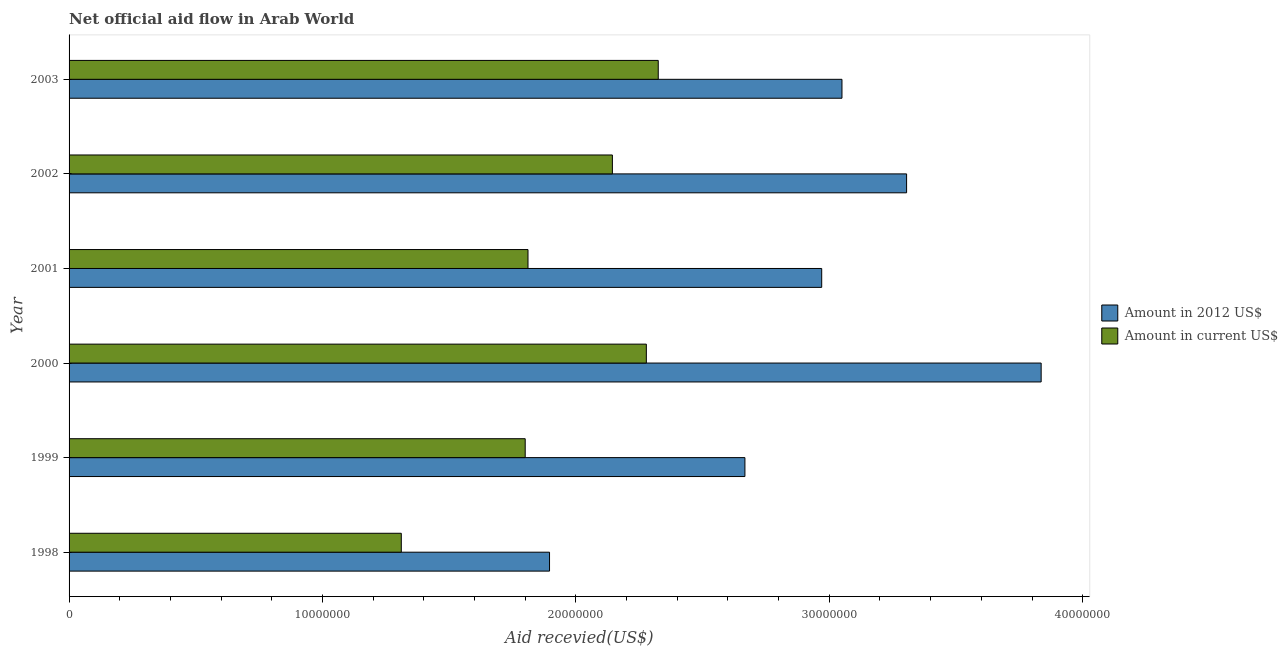How many different coloured bars are there?
Make the answer very short. 2. How many groups of bars are there?
Provide a short and direct response. 6. Are the number of bars on each tick of the Y-axis equal?
Offer a terse response. Yes. How many bars are there on the 2nd tick from the bottom?
Your answer should be very brief. 2. What is the label of the 2nd group of bars from the top?
Offer a very short reply. 2002. In how many cases, is the number of bars for a given year not equal to the number of legend labels?
Your answer should be compact. 0. What is the amount of aid received(expressed in 2012 us$) in 2002?
Your answer should be very brief. 3.30e+07. Across all years, what is the maximum amount of aid received(expressed in us$)?
Offer a very short reply. 2.32e+07. Across all years, what is the minimum amount of aid received(expressed in us$)?
Keep it short and to the point. 1.31e+07. In which year was the amount of aid received(expressed in 2012 us$) maximum?
Give a very brief answer. 2000. What is the total amount of aid received(expressed in us$) in the graph?
Give a very brief answer. 1.17e+08. What is the difference between the amount of aid received(expressed in 2012 us$) in 2002 and that in 2003?
Offer a terse response. 2.55e+06. What is the difference between the amount of aid received(expressed in us$) in 1998 and the amount of aid received(expressed in 2012 us$) in 1999?
Give a very brief answer. -1.36e+07. What is the average amount of aid received(expressed in us$) per year?
Your response must be concise. 1.94e+07. In the year 2002, what is the difference between the amount of aid received(expressed in us$) and amount of aid received(expressed in 2012 us$)?
Keep it short and to the point. -1.16e+07. What is the ratio of the amount of aid received(expressed in us$) in 2001 to that in 2003?
Provide a succinct answer. 0.78. What is the difference between the highest and the lowest amount of aid received(expressed in 2012 us$)?
Ensure brevity in your answer.  1.94e+07. In how many years, is the amount of aid received(expressed in us$) greater than the average amount of aid received(expressed in us$) taken over all years?
Offer a very short reply. 3. Is the sum of the amount of aid received(expressed in us$) in 2000 and 2001 greater than the maximum amount of aid received(expressed in 2012 us$) across all years?
Provide a succinct answer. Yes. What does the 1st bar from the top in 1999 represents?
Provide a short and direct response. Amount in current US$. What does the 1st bar from the bottom in 1999 represents?
Provide a short and direct response. Amount in 2012 US$. Are all the bars in the graph horizontal?
Make the answer very short. Yes. What is the difference between two consecutive major ticks on the X-axis?
Provide a succinct answer. 1.00e+07. Does the graph contain any zero values?
Your answer should be very brief. No. Where does the legend appear in the graph?
Provide a succinct answer. Center right. How many legend labels are there?
Offer a terse response. 2. What is the title of the graph?
Keep it short and to the point. Net official aid flow in Arab World. Does "Number of arrivals" appear as one of the legend labels in the graph?
Your response must be concise. No. What is the label or title of the X-axis?
Your answer should be compact. Aid recevied(US$). What is the label or title of the Y-axis?
Your response must be concise. Year. What is the Aid recevied(US$) of Amount in 2012 US$ in 1998?
Your response must be concise. 1.90e+07. What is the Aid recevied(US$) in Amount in current US$ in 1998?
Ensure brevity in your answer.  1.31e+07. What is the Aid recevied(US$) in Amount in 2012 US$ in 1999?
Your answer should be very brief. 2.67e+07. What is the Aid recevied(US$) in Amount in current US$ in 1999?
Keep it short and to the point. 1.80e+07. What is the Aid recevied(US$) of Amount in 2012 US$ in 2000?
Provide a short and direct response. 3.84e+07. What is the Aid recevied(US$) in Amount in current US$ in 2000?
Give a very brief answer. 2.28e+07. What is the Aid recevied(US$) in Amount in 2012 US$ in 2001?
Your answer should be very brief. 2.97e+07. What is the Aid recevied(US$) of Amount in current US$ in 2001?
Your answer should be compact. 1.81e+07. What is the Aid recevied(US$) in Amount in 2012 US$ in 2002?
Your response must be concise. 3.30e+07. What is the Aid recevied(US$) of Amount in current US$ in 2002?
Keep it short and to the point. 2.14e+07. What is the Aid recevied(US$) in Amount in 2012 US$ in 2003?
Provide a succinct answer. 3.05e+07. What is the Aid recevied(US$) of Amount in current US$ in 2003?
Offer a very short reply. 2.32e+07. Across all years, what is the maximum Aid recevied(US$) in Amount in 2012 US$?
Keep it short and to the point. 3.84e+07. Across all years, what is the maximum Aid recevied(US$) in Amount in current US$?
Offer a very short reply. 2.32e+07. Across all years, what is the minimum Aid recevied(US$) in Amount in 2012 US$?
Provide a succinct answer. 1.90e+07. Across all years, what is the minimum Aid recevied(US$) of Amount in current US$?
Make the answer very short. 1.31e+07. What is the total Aid recevied(US$) of Amount in 2012 US$ in the graph?
Your answer should be compact. 1.77e+08. What is the total Aid recevied(US$) in Amount in current US$ in the graph?
Your answer should be very brief. 1.17e+08. What is the difference between the Aid recevied(US$) of Amount in 2012 US$ in 1998 and that in 1999?
Provide a succinct answer. -7.71e+06. What is the difference between the Aid recevied(US$) in Amount in current US$ in 1998 and that in 1999?
Make the answer very short. -4.89e+06. What is the difference between the Aid recevied(US$) of Amount in 2012 US$ in 1998 and that in 2000?
Offer a terse response. -1.94e+07. What is the difference between the Aid recevied(US$) in Amount in current US$ in 1998 and that in 2000?
Your answer should be very brief. -9.67e+06. What is the difference between the Aid recevied(US$) of Amount in 2012 US$ in 1998 and that in 2001?
Provide a succinct answer. -1.07e+07. What is the difference between the Aid recevied(US$) in Amount in current US$ in 1998 and that in 2001?
Provide a succinct answer. -5.00e+06. What is the difference between the Aid recevied(US$) in Amount in 2012 US$ in 1998 and that in 2002?
Offer a terse response. -1.41e+07. What is the difference between the Aid recevied(US$) in Amount in current US$ in 1998 and that in 2002?
Ensure brevity in your answer.  -8.33e+06. What is the difference between the Aid recevied(US$) in Amount in 2012 US$ in 1998 and that in 2003?
Your answer should be very brief. -1.15e+07. What is the difference between the Aid recevied(US$) of Amount in current US$ in 1998 and that in 2003?
Give a very brief answer. -1.01e+07. What is the difference between the Aid recevied(US$) of Amount in 2012 US$ in 1999 and that in 2000?
Your response must be concise. -1.17e+07. What is the difference between the Aid recevied(US$) of Amount in current US$ in 1999 and that in 2000?
Provide a succinct answer. -4.78e+06. What is the difference between the Aid recevied(US$) of Amount in 2012 US$ in 1999 and that in 2001?
Make the answer very short. -3.03e+06. What is the difference between the Aid recevied(US$) in Amount in current US$ in 1999 and that in 2001?
Offer a terse response. -1.10e+05. What is the difference between the Aid recevied(US$) of Amount in 2012 US$ in 1999 and that in 2002?
Provide a succinct answer. -6.38e+06. What is the difference between the Aid recevied(US$) of Amount in current US$ in 1999 and that in 2002?
Offer a terse response. -3.44e+06. What is the difference between the Aid recevied(US$) in Amount in 2012 US$ in 1999 and that in 2003?
Provide a short and direct response. -3.83e+06. What is the difference between the Aid recevied(US$) in Amount in current US$ in 1999 and that in 2003?
Ensure brevity in your answer.  -5.25e+06. What is the difference between the Aid recevied(US$) of Amount in 2012 US$ in 2000 and that in 2001?
Offer a very short reply. 8.66e+06. What is the difference between the Aid recevied(US$) in Amount in current US$ in 2000 and that in 2001?
Your answer should be compact. 4.67e+06. What is the difference between the Aid recevied(US$) of Amount in 2012 US$ in 2000 and that in 2002?
Provide a succinct answer. 5.31e+06. What is the difference between the Aid recevied(US$) of Amount in current US$ in 2000 and that in 2002?
Provide a succinct answer. 1.34e+06. What is the difference between the Aid recevied(US$) in Amount in 2012 US$ in 2000 and that in 2003?
Your answer should be compact. 7.86e+06. What is the difference between the Aid recevied(US$) in Amount in current US$ in 2000 and that in 2003?
Offer a very short reply. -4.70e+05. What is the difference between the Aid recevied(US$) of Amount in 2012 US$ in 2001 and that in 2002?
Provide a succinct answer. -3.35e+06. What is the difference between the Aid recevied(US$) in Amount in current US$ in 2001 and that in 2002?
Provide a short and direct response. -3.33e+06. What is the difference between the Aid recevied(US$) of Amount in 2012 US$ in 2001 and that in 2003?
Offer a terse response. -8.00e+05. What is the difference between the Aid recevied(US$) of Amount in current US$ in 2001 and that in 2003?
Your answer should be compact. -5.14e+06. What is the difference between the Aid recevied(US$) in Amount in 2012 US$ in 2002 and that in 2003?
Your answer should be compact. 2.55e+06. What is the difference between the Aid recevied(US$) in Amount in current US$ in 2002 and that in 2003?
Your answer should be very brief. -1.81e+06. What is the difference between the Aid recevied(US$) of Amount in 2012 US$ in 1998 and the Aid recevied(US$) of Amount in current US$ in 1999?
Give a very brief answer. 9.60e+05. What is the difference between the Aid recevied(US$) of Amount in 2012 US$ in 1998 and the Aid recevied(US$) of Amount in current US$ in 2000?
Your answer should be very brief. -3.82e+06. What is the difference between the Aid recevied(US$) of Amount in 2012 US$ in 1998 and the Aid recevied(US$) of Amount in current US$ in 2001?
Provide a succinct answer. 8.50e+05. What is the difference between the Aid recevied(US$) in Amount in 2012 US$ in 1998 and the Aid recevied(US$) in Amount in current US$ in 2002?
Keep it short and to the point. -2.48e+06. What is the difference between the Aid recevied(US$) of Amount in 2012 US$ in 1998 and the Aid recevied(US$) of Amount in current US$ in 2003?
Offer a very short reply. -4.29e+06. What is the difference between the Aid recevied(US$) of Amount in 2012 US$ in 1999 and the Aid recevied(US$) of Amount in current US$ in 2000?
Make the answer very short. 3.89e+06. What is the difference between the Aid recevied(US$) of Amount in 2012 US$ in 1999 and the Aid recevied(US$) of Amount in current US$ in 2001?
Offer a very short reply. 8.56e+06. What is the difference between the Aid recevied(US$) in Amount in 2012 US$ in 1999 and the Aid recevied(US$) in Amount in current US$ in 2002?
Offer a very short reply. 5.23e+06. What is the difference between the Aid recevied(US$) of Amount in 2012 US$ in 1999 and the Aid recevied(US$) of Amount in current US$ in 2003?
Provide a short and direct response. 3.42e+06. What is the difference between the Aid recevied(US$) in Amount in 2012 US$ in 2000 and the Aid recevied(US$) in Amount in current US$ in 2001?
Your answer should be compact. 2.02e+07. What is the difference between the Aid recevied(US$) in Amount in 2012 US$ in 2000 and the Aid recevied(US$) in Amount in current US$ in 2002?
Your response must be concise. 1.69e+07. What is the difference between the Aid recevied(US$) in Amount in 2012 US$ in 2000 and the Aid recevied(US$) in Amount in current US$ in 2003?
Your answer should be compact. 1.51e+07. What is the difference between the Aid recevied(US$) of Amount in 2012 US$ in 2001 and the Aid recevied(US$) of Amount in current US$ in 2002?
Offer a very short reply. 8.26e+06. What is the difference between the Aid recevied(US$) in Amount in 2012 US$ in 2001 and the Aid recevied(US$) in Amount in current US$ in 2003?
Your answer should be compact. 6.45e+06. What is the difference between the Aid recevied(US$) of Amount in 2012 US$ in 2002 and the Aid recevied(US$) of Amount in current US$ in 2003?
Provide a short and direct response. 9.80e+06. What is the average Aid recevied(US$) of Amount in 2012 US$ per year?
Provide a succinct answer. 2.95e+07. What is the average Aid recevied(US$) in Amount in current US$ per year?
Provide a succinct answer. 1.94e+07. In the year 1998, what is the difference between the Aid recevied(US$) in Amount in 2012 US$ and Aid recevied(US$) in Amount in current US$?
Your answer should be compact. 5.85e+06. In the year 1999, what is the difference between the Aid recevied(US$) in Amount in 2012 US$ and Aid recevied(US$) in Amount in current US$?
Keep it short and to the point. 8.67e+06. In the year 2000, what is the difference between the Aid recevied(US$) in Amount in 2012 US$ and Aid recevied(US$) in Amount in current US$?
Your answer should be compact. 1.56e+07. In the year 2001, what is the difference between the Aid recevied(US$) in Amount in 2012 US$ and Aid recevied(US$) in Amount in current US$?
Offer a terse response. 1.16e+07. In the year 2002, what is the difference between the Aid recevied(US$) in Amount in 2012 US$ and Aid recevied(US$) in Amount in current US$?
Your response must be concise. 1.16e+07. In the year 2003, what is the difference between the Aid recevied(US$) of Amount in 2012 US$ and Aid recevied(US$) of Amount in current US$?
Provide a succinct answer. 7.25e+06. What is the ratio of the Aid recevied(US$) in Amount in 2012 US$ in 1998 to that in 1999?
Ensure brevity in your answer.  0.71. What is the ratio of the Aid recevied(US$) of Amount in current US$ in 1998 to that in 1999?
Your answer should be very brief. 0.73. What is the ratio of the Aid recevied(US$) in Amount in 2012 US$ in 1998 to that in 2000?
Your answer should be compact. 0.49. What is the ratio of the Aid recevied(US$) of Amount in current US$ in 1998 to that in 2000?
Offer a terse response. 0.58. What is the ratio of the Aid recevied(US$) of Amount in 2012 US$ in 1998 to that in 2001?
Offer a terse response. 0.64. What is the ratio of the Aid recevied(US$) in Amount in current US$ in 1998 to that in 2001?
Offer a terse response. 0.72. What is the ratio of the Aid recevied(US$) in Amount in 2012 US$ in 1998 to that in 2002?
Keep it short and to the point. 0.57. What is the ratio of the Aid recevied(US$) of Amount in current US$ in 1998 to that in 2002?
Your response must be concise. 0.61. What is the ratio of the Aid recevied(US$) in Amount in 2012 US$ in 1998 to that in 2003?
Provide a succinct answer. 0.62. What is the ratio of the Aid recevied(US$) of Amount in current US$ in 1998 to that in 2003?
Provide a succinct answer. 0.56. What is the ratio of the Aid recevied(US$) in Amount in 2012 US$ in 1999 to that in 2000?
Your answer should be very brief. 0.7. What is the ratio of the Aid recevied(US$) in Amount in current US$ in 1999 to that in 2000?
Provide a succinct answer. 0.79. What is the ratio of the Aid recevied(US$) in Amount in 2012 US$ in 1999 to that in 2001?
Keep it short and to the point. 0.9. What is the ratio of the Aid recevied(US$) of Amount in 2012 US$ in 1999 to that in 2002?
Offer a terse response. 0.81. What is the ratio of the Aid recevied(US$) in Amount in current US$ in 1999 to that in 2002?
Your answer should be compact. 0.84. What is the ratio of the Aid recevied(US$) in Amount in 2012 US$ in 1999 to that in 2003?
Ensure brevity in your answer.  0.87. What is the ratio of the Aid recevied(US$) of Amount in current US$ in 1999 to that in 2003?
Provide a short and direct response. 0.77. What is the ratio of the Aid recevied(US$) of Amount in 2012 US$ in 2000 to that in 2001?
Your answer should be compact. 1.29. What is the ratio of the Aid recevied(US$) of Amount in current US$ in 2000 to that in 2001?
Your answer should be very brief. 1.26. What is the ratio of the Aid recevied(US$) in Amount in 2012 US$ in 2000 to that in 2002?
Make the answer very short. 1.16. What is the ratio of the Aid recevied(US$) of Amount in 2012 US$ in 2000 to that in 2003?
Give a very brief answer. 1.26. What is the ratio of the Aid recevied(US$) in Amount in current US$ in 2000 to that in 2003?
Give a very brief answer. 0.98. What is the ratio of the Aid recevied(US$) in Amount in 2012 US$ in 2001 to that in 2002?
Keep it short and to the point. 0.9. What is the ratio of the Aid recevied(US$) in Amount in current US$ in 2001 to that in 2002?
Make the answer very short. 0.84. What is the ratio of the Aid recevied(US$) of Amount in 2012 US$ in 2001 to that in 2003?
Your answer should be very brief. 0.97. What is the ratio of the Aid recevied(US$) in Amount in current US$ in 2001 to that in 2003?
Your answer should be very brief. 0.78. What is the ratio of the Aid recevied(US$) of Amount in 2012 US$ in 2002 to that in 2003?
Offer a very short reply. 1.08. What is the ratio of the Aid recevied(US$) of Amount in current US$ in 2002 to that in 2003?
Offer a very short reply. 0.92. What is the difference between the highest and the second highest Aid recevied(US$) in Amount in 2012 US$?
Ensure brevity in your answer.  5.31e+06. What is the difference between the highest and the lowest Aid recevied(US$) in Amount in 2012 US$?
Give a very brief answer. 1.94e+07. What is the difference between the highest and the lowest Aid recevied(US$) of Amount in current US$?
Give a very brief answer. 1.01e+07. 